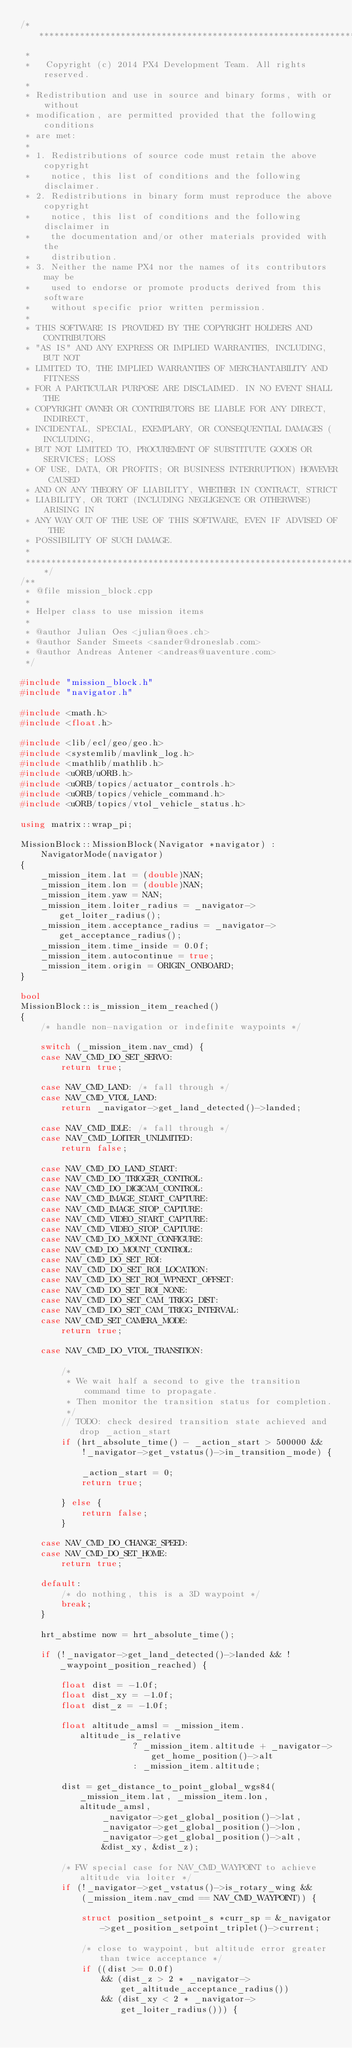<code> <loc_0><loc_0><loc_500><loc_500><_C++_>/****************************************************************************
 *
 *   Copyright (c) 2014 PX4 Development Team. All rights reserved.
 *
 * Redistribution and use in source and binary forms, with or without
 * modification, are permitted provided that the following conditions
 * are met:
 *
 * 1. Redistributions of source code must retain the above copyright
 *    notice, this list of conditions and the following disclaimer.
 * 2. Redistributions in binary form must reproduce the above copyright
 *    notice, this list of conditions and the following disclaimer in
 *    the documentation and/or other materials provided with the
 *    distribution.
 * 3. Neither the name PX4 nor the names of its contributors may be
 *    used to endorse or promote products derived from this software
 *    without specific prior written permission.
 *
 * THIS SOFTWARE IS PROVIDED BY THE COPYRIGHT HOLDERS AND CONTRIBUTORS
 * "AS IS" AND ANY EXPRESS OR IMPLIED WARRANTIES, INCLUDING, BUT NOT
 * LIMITED TO, THE IMPLIED WARRANTIES OF MERCHANTABILITY AND FITNESS
 * FOR A PARTICULAR PURPOSE ARE DISCLAIMED. IN NO EVENT SHALL THE
 * COPYRIGHT OWNER OR CONTRIBUTORS BE LIABLE FOR ANY DIRECT, INDIRECT,
 * INCIDENTAL, SPECIAL, EXEMPLARY, OR CONSEQUENTIAL DAMAGES (INCLUDING,
 * BUT NOT LIMITED TO, PROCUREMENT OF SUBSTITUTE GOODS OR SERVICES; LOSS
 * OF USE, DATA, OR PROFITS; OR BUSINESS INTERRUPTION) HOWEVER CAUSED
 * AND ON ANY THEORY OF LIABILITY, WHETHER IN CONTRACT, STRICT
 * LIABILITY, OR TORT (INCLUDING NEGLIGENCE OR OTHERWISE) ARISING IN
 * ANY WAY OUT OF THE USE OF THIS SOFTWARE, EVEN IF ADVISED OF THE
 * POSSIBILITY OF SUCH DAMAGE.
 *
 ****************************************************************************/
/**
 * @file mission_block.cpp
 *
 * Helper class to use mission items
 *
 * @author Julian Oes <julian@oes.ch>
 * @author Sander Smeets <sander@droneslab.com>
 * @author Andreas Antener <andreas@uaventure.com>
 */

#include "mission_block.h"
#include "navigator.h"

#include <math.h>
#include <float.h>

#include <lib/ecl/geo/geo.h>
#include <systemlib/mavlink_log.h>
#include <mathlib/mathlib.h>
#include <uORB/uORB.h>
#include <uORB/topics/actuator_controls.h>
#include <uORB/topics/vehicle_command.h>
#include <uORB/topics/vtol_vehicle_status.h>

using matrix::wrap_pi;

MissionBlock::MissionBlock(Navigator *navigator) :
	NavigatorMode(navigator)
{
	_mission_item.lat = (double)NAN;
	_mission_item.lon = (double)NAN;
	_mission_item.yaw = NAN;
	_mission_item.loiter_radius = _navigator->get_loiter_radius();
	_mission_item.acceptance_radius = _navigator->get_acceptance_radius();
	_mission_item.time_inside = 0.0f;
	_mission_item.autocontinue = true;
	_mission_item.origin = ORIGIN_ONBOARD;
}

bool
MissionBlock::is_mission_item_reached()
{
	/* handle non-navigation or indefinite waypoints */

	switch (_mission_item.nav_cmd) {
	case NAV_CMD_DO_SET_SERVO:
		return true;

	case NAV_CMD_LAND: /* fall through */
	case NAV_CMD_VTOL_LAND:
		return _navigator->get_land_detected()->landed;

	case NAV_CMD_IDLE: /* fall through */
	case NAV_CMD_LOITER_UNLIMITED:
		return false;

	case NAV_CMD_DO_LAND_START:
	case NAV_CMD_DO_TRIGGER_CONTROL:
	case NAV_CMD_DO_DIGICAM_CONTROL:
	case NAV_CMD_IMAGE_START_CAPTURE:
	case NAV_CMD_IMAGE_STOP_CAPTURE:
	case NAV_CMD_VIDEO_START_CAPTURE:
	case NAV_CMD_VIDEO_STOP_CAPTURE:
	case NAV_CMD_DO_MOUNT_CONFIGURE:
	case NAV_CMD_DO_MOUNT_CONTROL:
	case NAV_CMD_DO_SET_ROI:
	case NAV_CMD_DO_SET_ROI_LOCATION:
	case NAV_CMD_DO_SET_ROI_WPNEXT_OFFSET:
	case NAV_CMD_DO_SET_ROI_NONE:
	case NAV_CMD_DO_SET_CAM_TRIGG_DIST:
	case NAV_CMD_DO_SET_CAM_TRIGG_INTERVAL:
	case NAV_CMD_SET_CAMERA_MODE:
		return true;

	case NAV_CMD_DO_VTOL_TRANSITION:

		/*
		 * We wait half a second to give the transition command time to propagate.
		 * Then monitor the transition status for completion.
		 */
		// TODO: check desired transition state achieved and drop _action_start
		if (hrt_absolute_time() - _action_start > 500000 &&
		    !_navigator->get_vstatus()->in_transition_mode) {

			_action_start = 0;
			return true;

		} else {
			return false;
		}

	case NAV_CMD_DO_CHANGE_SPEED:
	case NAV_CMD_DO_SET_HOME:
		return true;

	default:
		/* do nothing, this is a 3D waypoint */
		break;
	}

	hrt_abstime now = hrt_absolute_time();

	if (!_navigator->get_land_detected()->landed && !_waypoint_position_reached) {

		float dist = -1.0f;
		float dist_xy = -1.0f;
		float dist_z = -1.0f;

		float altitude_amsl = _mission_item.altitude_is_relative
				      ? _mission_item.altitude + _navigator->get_home_position()->alt
				      : _mission_item.altitude;

		dist = get_distance_to_point_global_wgs84(_mission_item.lat, _mission_item.lon, altitude_amsl,
				_navigator->get_global_position()->lat,
				_navigator->get_global_position()->lon,
				_navigator->get_global_position()->alt,
				&dist_xy, &dist_z);

		/* FW special case for NAV_CMD_WAYPOINT to achieve altitude via loiter */
		if (!_navigator->get_vstatus()->is_rotary_wing &&
		    (_mission_item.nav_cmd == NAV_CMD_WAYPOINT)) {

			struct position_setpoint_s *curr_sp = &_navigator->get_position_setpoint_triplet()->current;

			/* close to waypoint, but altitude error greater than twice acceptance */
			if ((dist >= 0.0f)
			    && (dist_z > 2 * _navigator->get_altitude_acceptance_radius())
			    && (dist_xy < 2 * _navigator->get_loiter_radius())) {
</code> 